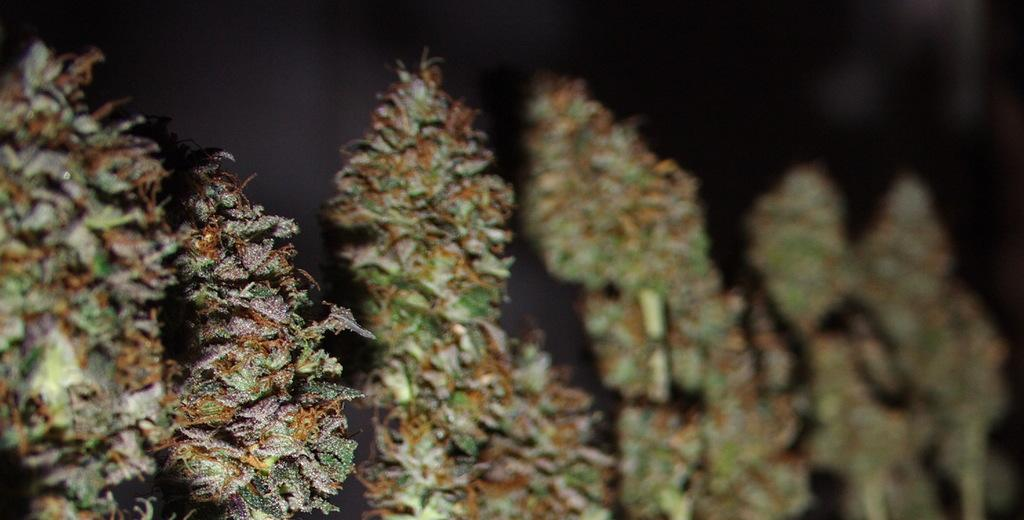What type of photography is used in the image? The image is a macro photography of plants. Can you describe any specific details about the plants in the image? Unfortunately, the right side of the image is blurred, so it is difficult to provide specific details about the plants. How many books are stacked on the toothbrush in the image? There are no books or toothbrushes present in the image; it is a macro photography of plants. 